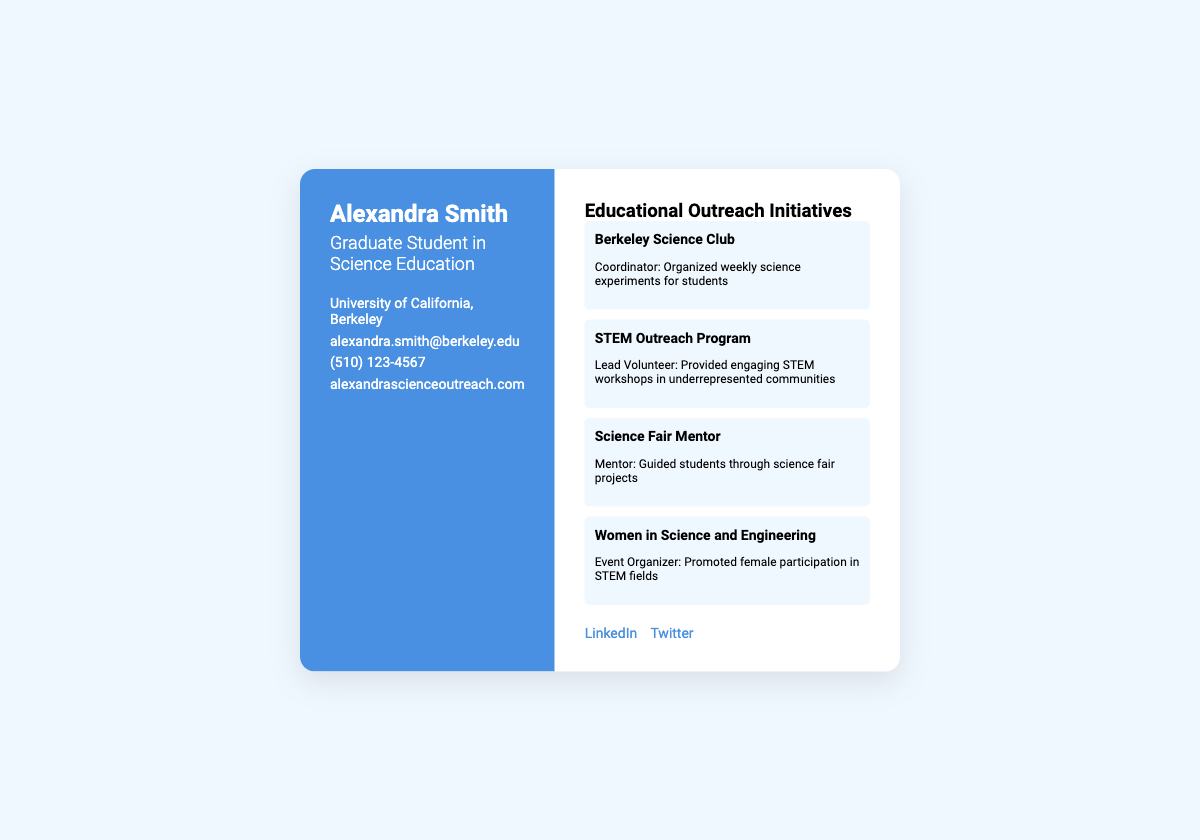What is Alexandra Smith's title? Alexandra's title is listed prominently in the document, which states she is a Graduate Student in Science Education.
Answer: Graduate Student in Science Education Where does Alexandra study? The document specifies the educational institution associated with Alexandra, which is the University of California, Berkeley.
Answer: University of California, Berkeley What is Alexandra's email address? The document contains a specific section for contact information, including her email, which is provided as alexandra.smith@berkeley.edu.
Answer: alexandra.smith@berkeley.edu How many educational outreach initiatives are listed? By counting the initiatives in the provided section, we identify that there are four distinct initiatives listed.
Answer: Four What role did Alexandra serve in the STEM Outreach Program? The document outlines specific roles for each initiative, indicating that she served as the Lead Volunteer for this program.
Answer: Lead Volunteer What is the purpose of the Women in Science and Engineering initiative? The description in the document conveys that the initiative promotes female participation in STEM fields.
Answer: Promote female participation in STEM fields What type of document is this? The structure and content of the document suggest it is used for personal branding and networking, characteristic of a business card.
Answer: Business card Which social media platform is listed first? Examining the links provided in the social media section indicates that LinkedIn is mentioned before Twitter.
Answer: LinkedIn What type of activities does the Berkeley Science Club involve? The document presents this initiative as involving the organization of weekly science experiments for students.
Answer: Weekly science experiments 